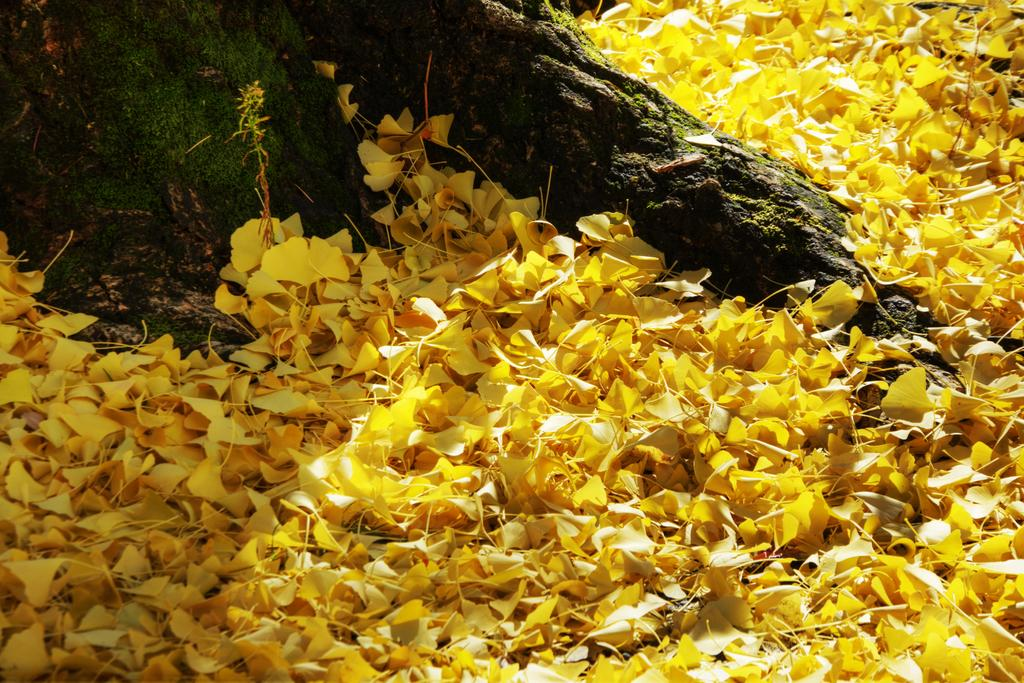What type of flowers are on the ground in the image? There are yellow flower petals on the ground in the image. What can be seen on the left side of the image? There is a tree trunk on the left side of the image. What type of ring can be seen on the tree trunk in the image? There is no ring present on the tree trunk in the image. What type of skin is visible on the tree trunk in the image? The tree trunk in the image is made of wood, not skin. 